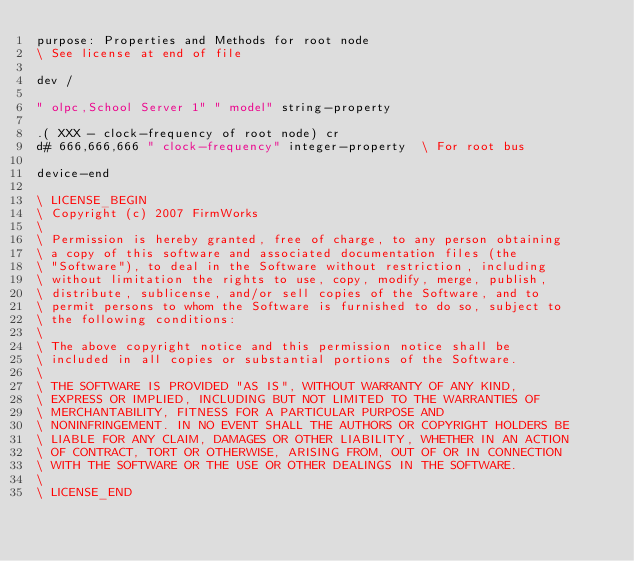Convert code to text. <code><loc_0><loc_0><loc_500><loc_500><_Forth_>purpose: Properties and Methods for root node
\ See license at end of file

dev /

" olpc,School Server 1" " model" string-property

.( XXX - clock-frequency of root node) cr
d# 666,666,666 " clock-frequency" integer-property  \ For root bus

device-end

\ LICENSE_BEGIN
\ Copyright (c) 2007 FirmWorks
\ 
\ Permission is hereby granted, free of charge, to any person obtaining
\ a copy of this software and associated documentation files (the
\ "Software"), to deal in the Software without restriction, including
\ without limitation the rights to use, copy, modify, merge, publish,
\ distribute, sublicense, and/or sell copies of the Software, and to
\ permit persons to whom the Software is furnished to do so, subject to
\ the following conditions:
\ 
\ The above copyright notice and this permission notice shall be
\ included in all copies or substantial portions of the Software.
\ 
\ THE SOFTWARE IS PROVIDED "AS IS", WITHOUT WARRANTY OF ANY KIND,
\ EXPRESS OR IMPLIED, INCLUDING BUT NOT LIMITED TO THE WARRANTIES OF
\ MERCHANTABILITY, FITNESS FOR A PARTICULAR PURPOSE AND
\ NONINFRINGEMENT. IN NO EVENT SHALL THE AUTHORS OR COPYRIGHT HOLDERS BE
\ LIABLE FOR ANY CLAIM, DAMAGES OR OTHER LIABILITY, WHETHER IN AN ACTION
\ OF CONTRACT, TORT OR OTHERWISE, ARISING FROM, OUT OF OR IN CONNECTION
\ WITH THE SOFTWARE OR THE USE OR OTHER DEALINGS IN THE SOFTWARE.
\
\ LICENSE_END
</code> 